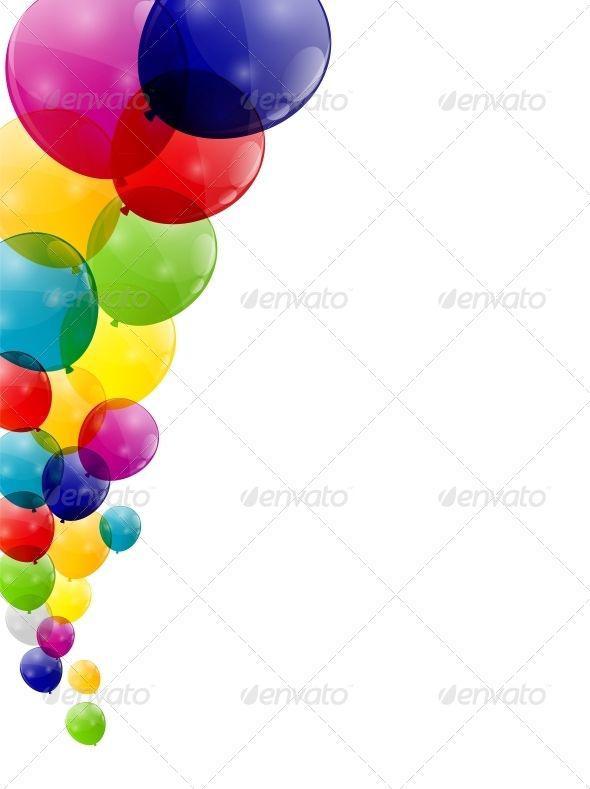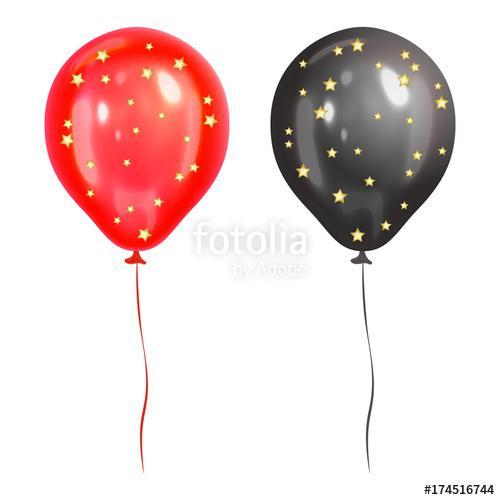The first image is the image on the left, the second image is the image on the right. Examine the images to the left and right. Is the description "The balloons are arranged vertically in one image, horizontally in the other." accurate? Answer yes or no. Yes. The first image is the image on the left, the second image is the image on the right. For the images shown, is this caption "One image shows round balloons with dangling, non-straight strings under them, and contains no more than four balloons." true? Answer yes or no. Yes. 